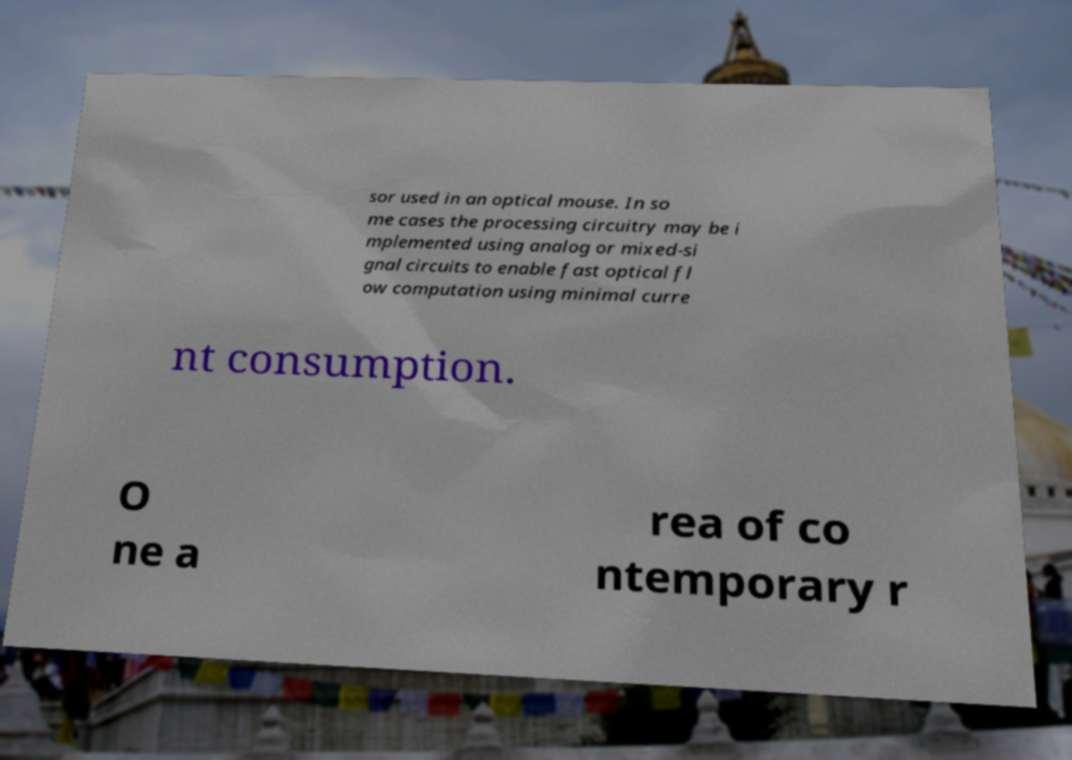For documentation purposes, I need the text within this image transcribed. Could you provide that? sor used in an optical mouse. In so me cases the processing circuitry may be i mplemented using analog or mixed-si gnal circuits to enable fast optical fl ow computation using minimal curre nt consumption. O ne a rea of co ntemporary r 